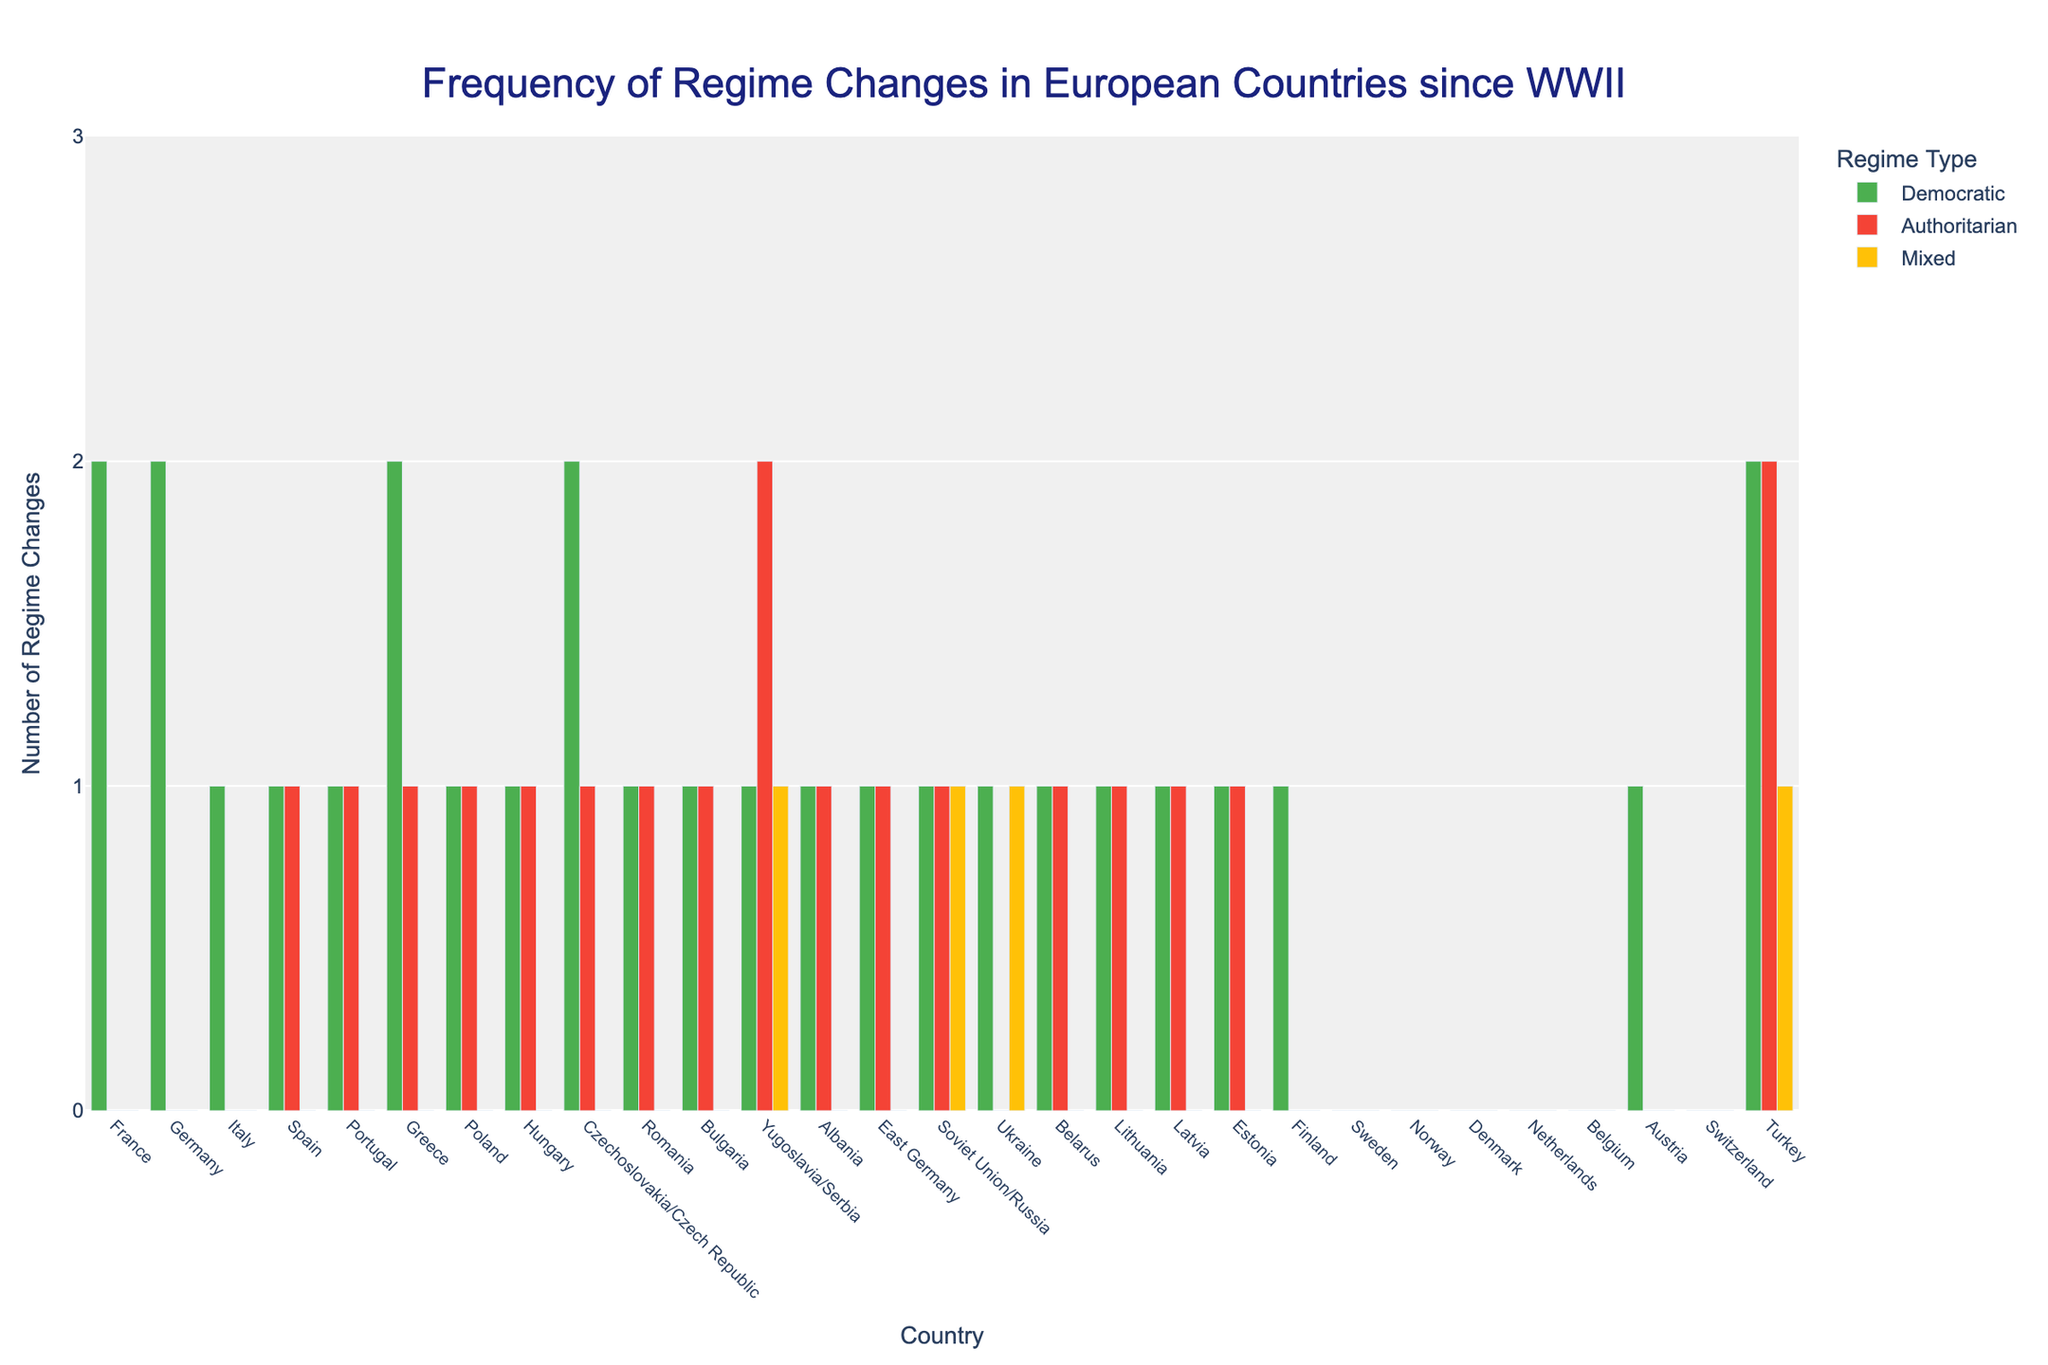Which country experienced the highest number of regime changes overall? By visually inspecting the heights of the bars for each country and summing the regime changes (Democratic, Authoritarian, and Mixed), we find that Yugoslavia/Serbia has the highest total with 1 Democratic, 2 Authoritarian, and 1 Mixed regime changes, summing to 4 in total.
Answer: Yugoslavia/Serbia Which countries have had both Democratic and Authoritarian regime changes but no Mixed regimes? By observing the colors (green for Democratic, red for Authoritarian, and yellow for Mixed), we identify countries with both green and red bars but no yellow bar. Such countries include Spain, Portugal, Greece, Poland, Hungary, Czechoslovakia/Czech Republic, East Germany, Lithuania, Latvia, Estonia, and Belarus.
Answer: Spain, Portugal, Greece, Poland, Hungary, Czechoslovakia/Czech Republic, East Germany, Lithuania, Latvia, Estonia, Belarus Which countries have not experienced any regime changes since World War II? We look for countries that have no bars of any color (Democratic, Authoritarian, or Mixed). These countries are Sweden, Norway, Denmark, Netherlands, Belgium, and Switzerland.
Answer: Sweden, Norway, Denmark, Netherlands, Belgium, Switzerland How many total regime changes have occurred in Turkey, and what types are they? By summing the values of the bars for Turkey: 2 Democratic, 2 Authoritarian, and 1 Mixed, we find a total of 5 regime changes.
Answer: 5 (2 Democratic, 2 Authoritarian, 1 Mixed) Which countries have experienced exactly one regime change, and what type is it? By identifying countries with a single bar of any color: Italy (Democratic), Finland (Democratic), Spain (Democratic), Portugal (Democratic), Romania (Democratic), Bulgaria (Democratic), and Albania (Democratic).
Answer: Italy (Democratic), Finland (Democratic), Spain (Democratic), Portugal (Democratic), Romania (Democratic), Bulgaria (Democratic), Albania (Democratic) Compare the number of Democratic and Authoritarian regime changes in Greece. Which is greater, and by how much? Greece has 2 Democratic and 1 Authoritarian regime changes. The number of Democratic regime changes is greater by 1.
Answer: Democratic, by 1 